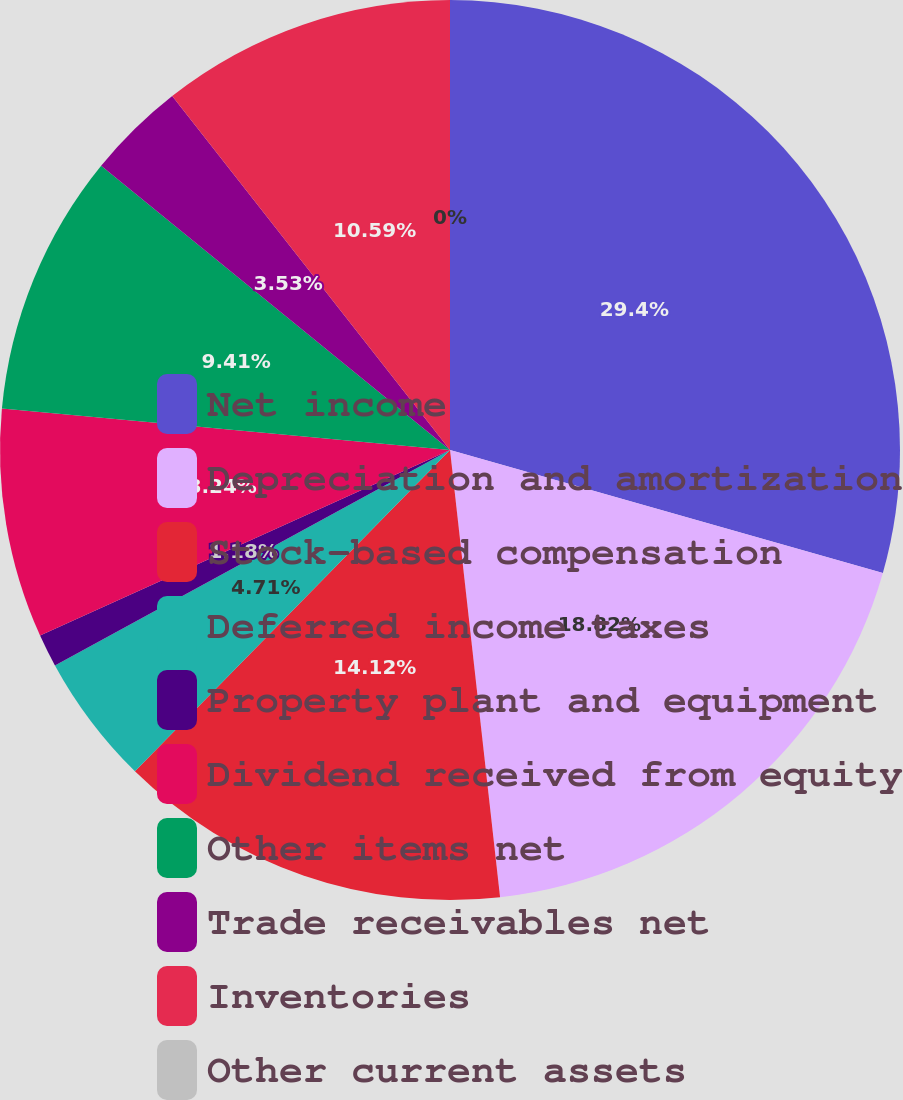Convert chart to OTSL. <chart><loc_0><loc_0><loc_500><loc_500><pie_chart><fcel>Net income<fcel>Depreciation and amortization<fcel>Stock-based compensation<fcel>Deferred income taxes<fcel>Property plant and equipment<fcel>Dividend received from equity<fcel>Other items net<fcel>Trade receivables net<fcel>Inventories<fcel>Other current assets<nl><fcel>29.41%<fcel>18.82%<fcel>14.12%<fcel>4.71%<fcel>1.18%<fcel>8.24%<fcel>9.41%<fcel>3.53%<fcel>10.59%<fcel>0.0%<nl></chart> 